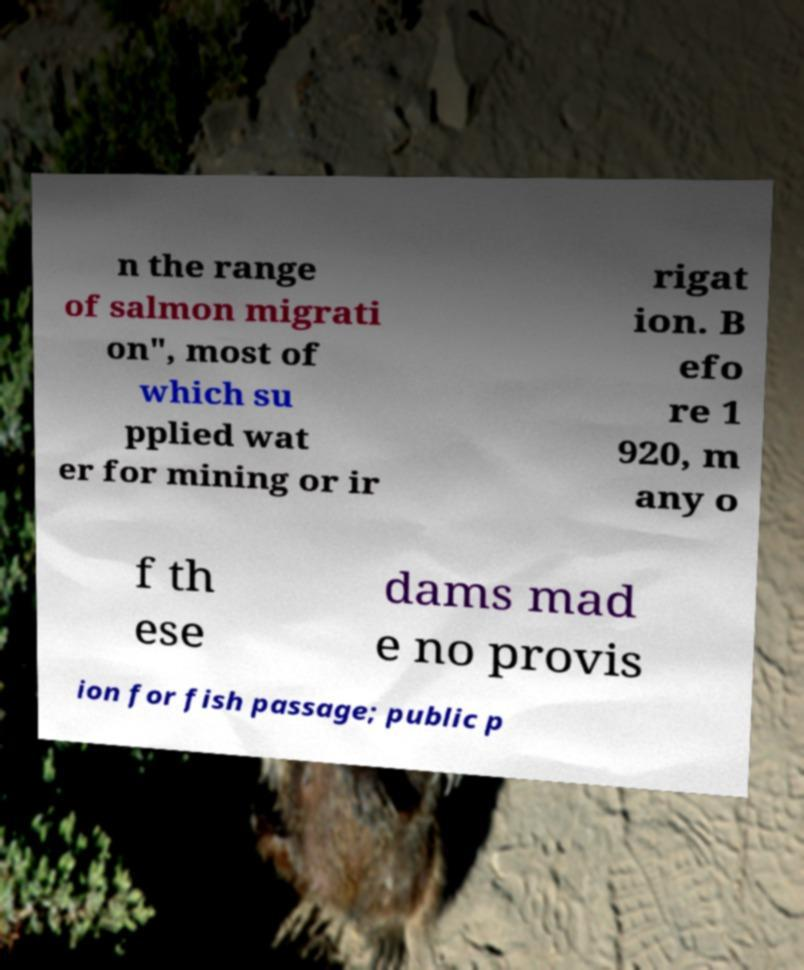Could you assist in decoding the text presented in this image and type it out clearly? n the range of salmon migrati on", most of which su pplied wat er for mining or ir rigat ion. B efo re 1 920, m any o f th ese dams mad e no provis ion for fish passage; public p 